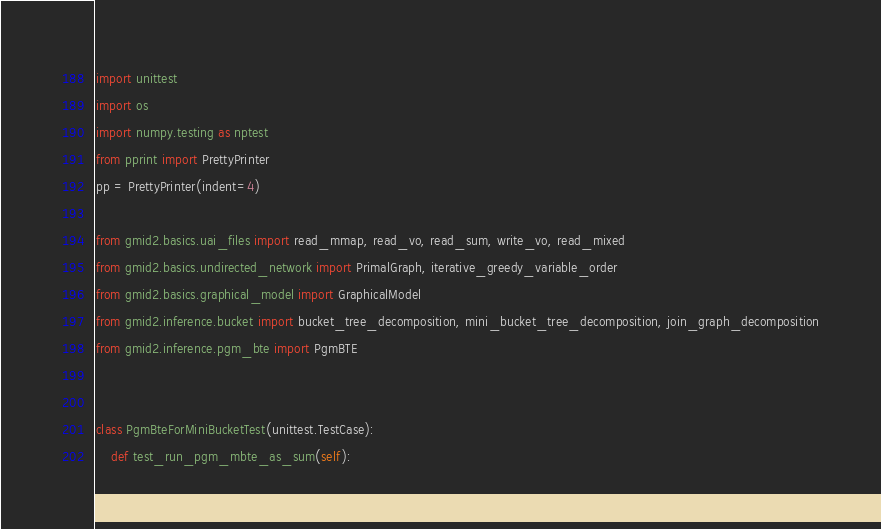<code> <loc_0><loc_0><loc_500><loc_500><_Python_>import unittest
import os
import numpy.testing as nptest
from pprint import PrettyPrinter
pp = PrettyPrinter(indent=4)

from gmid2.basics.uai_files import read_mmap, read_vo, read_sum, write_vo, read_mixed
from gmid2.basics.undirected_network import PrimalGraph, iterative_greedy_variable_order
from gmid2.basics.graphical_model import GraphicalModel
from gmid2.inference.bucket import bucket_tree_decomposition, mini_bucket_tree_decomposition, join_graph_decomposition
from gmid2.inference.pgm_bte import PgmBTE


class PgmBteForMiniBucketTest(unittest.TestCase):
    def test_run_pgm_mbte_as_sum(self):</code> 